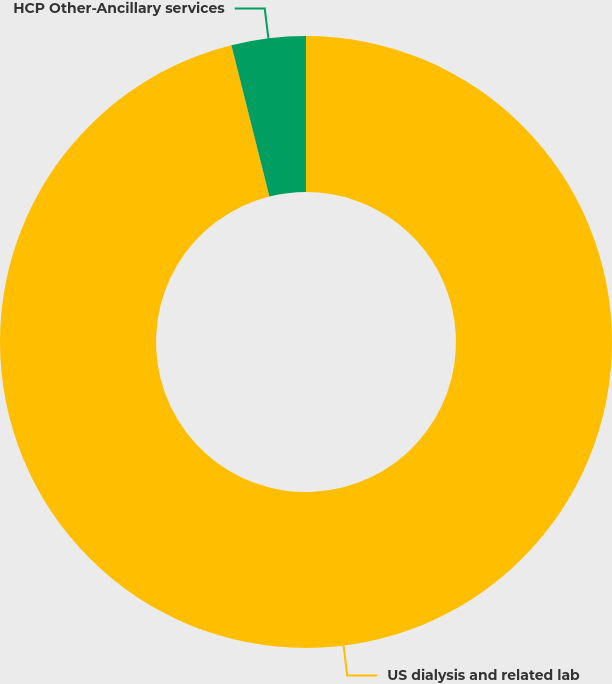<chart> <loc_0><loc_0><loc_500><loc_500><pie_chart><fcel>US dialysis and related lab<fcel>HCP Other-Ancillary services<nl><fcel>96.08%<fcel>3.92%<nl></chart> 